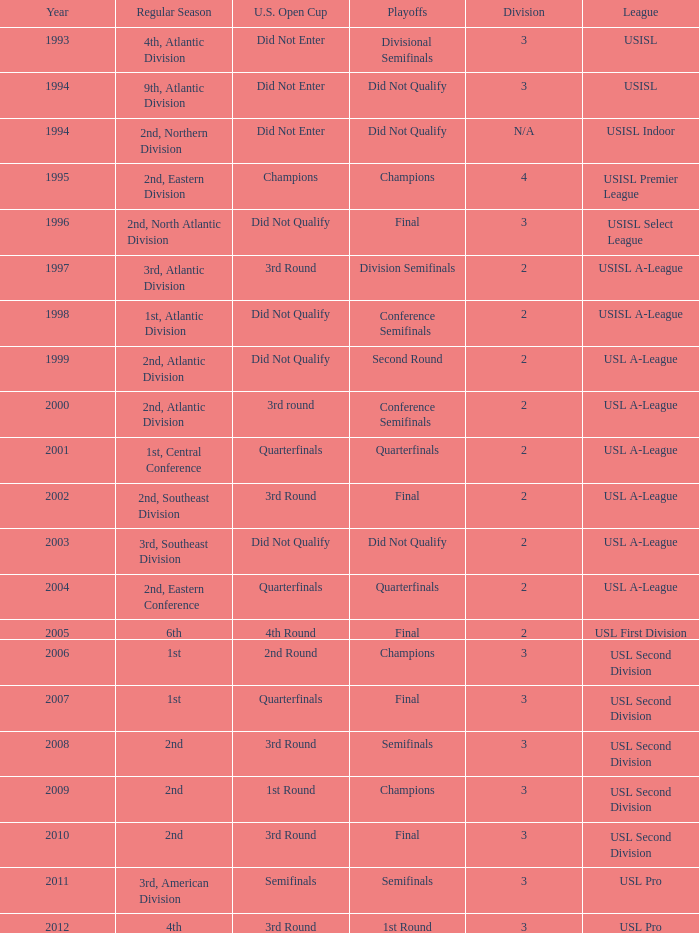Which round is u.s. open cup division semifinals 3rd Round. 